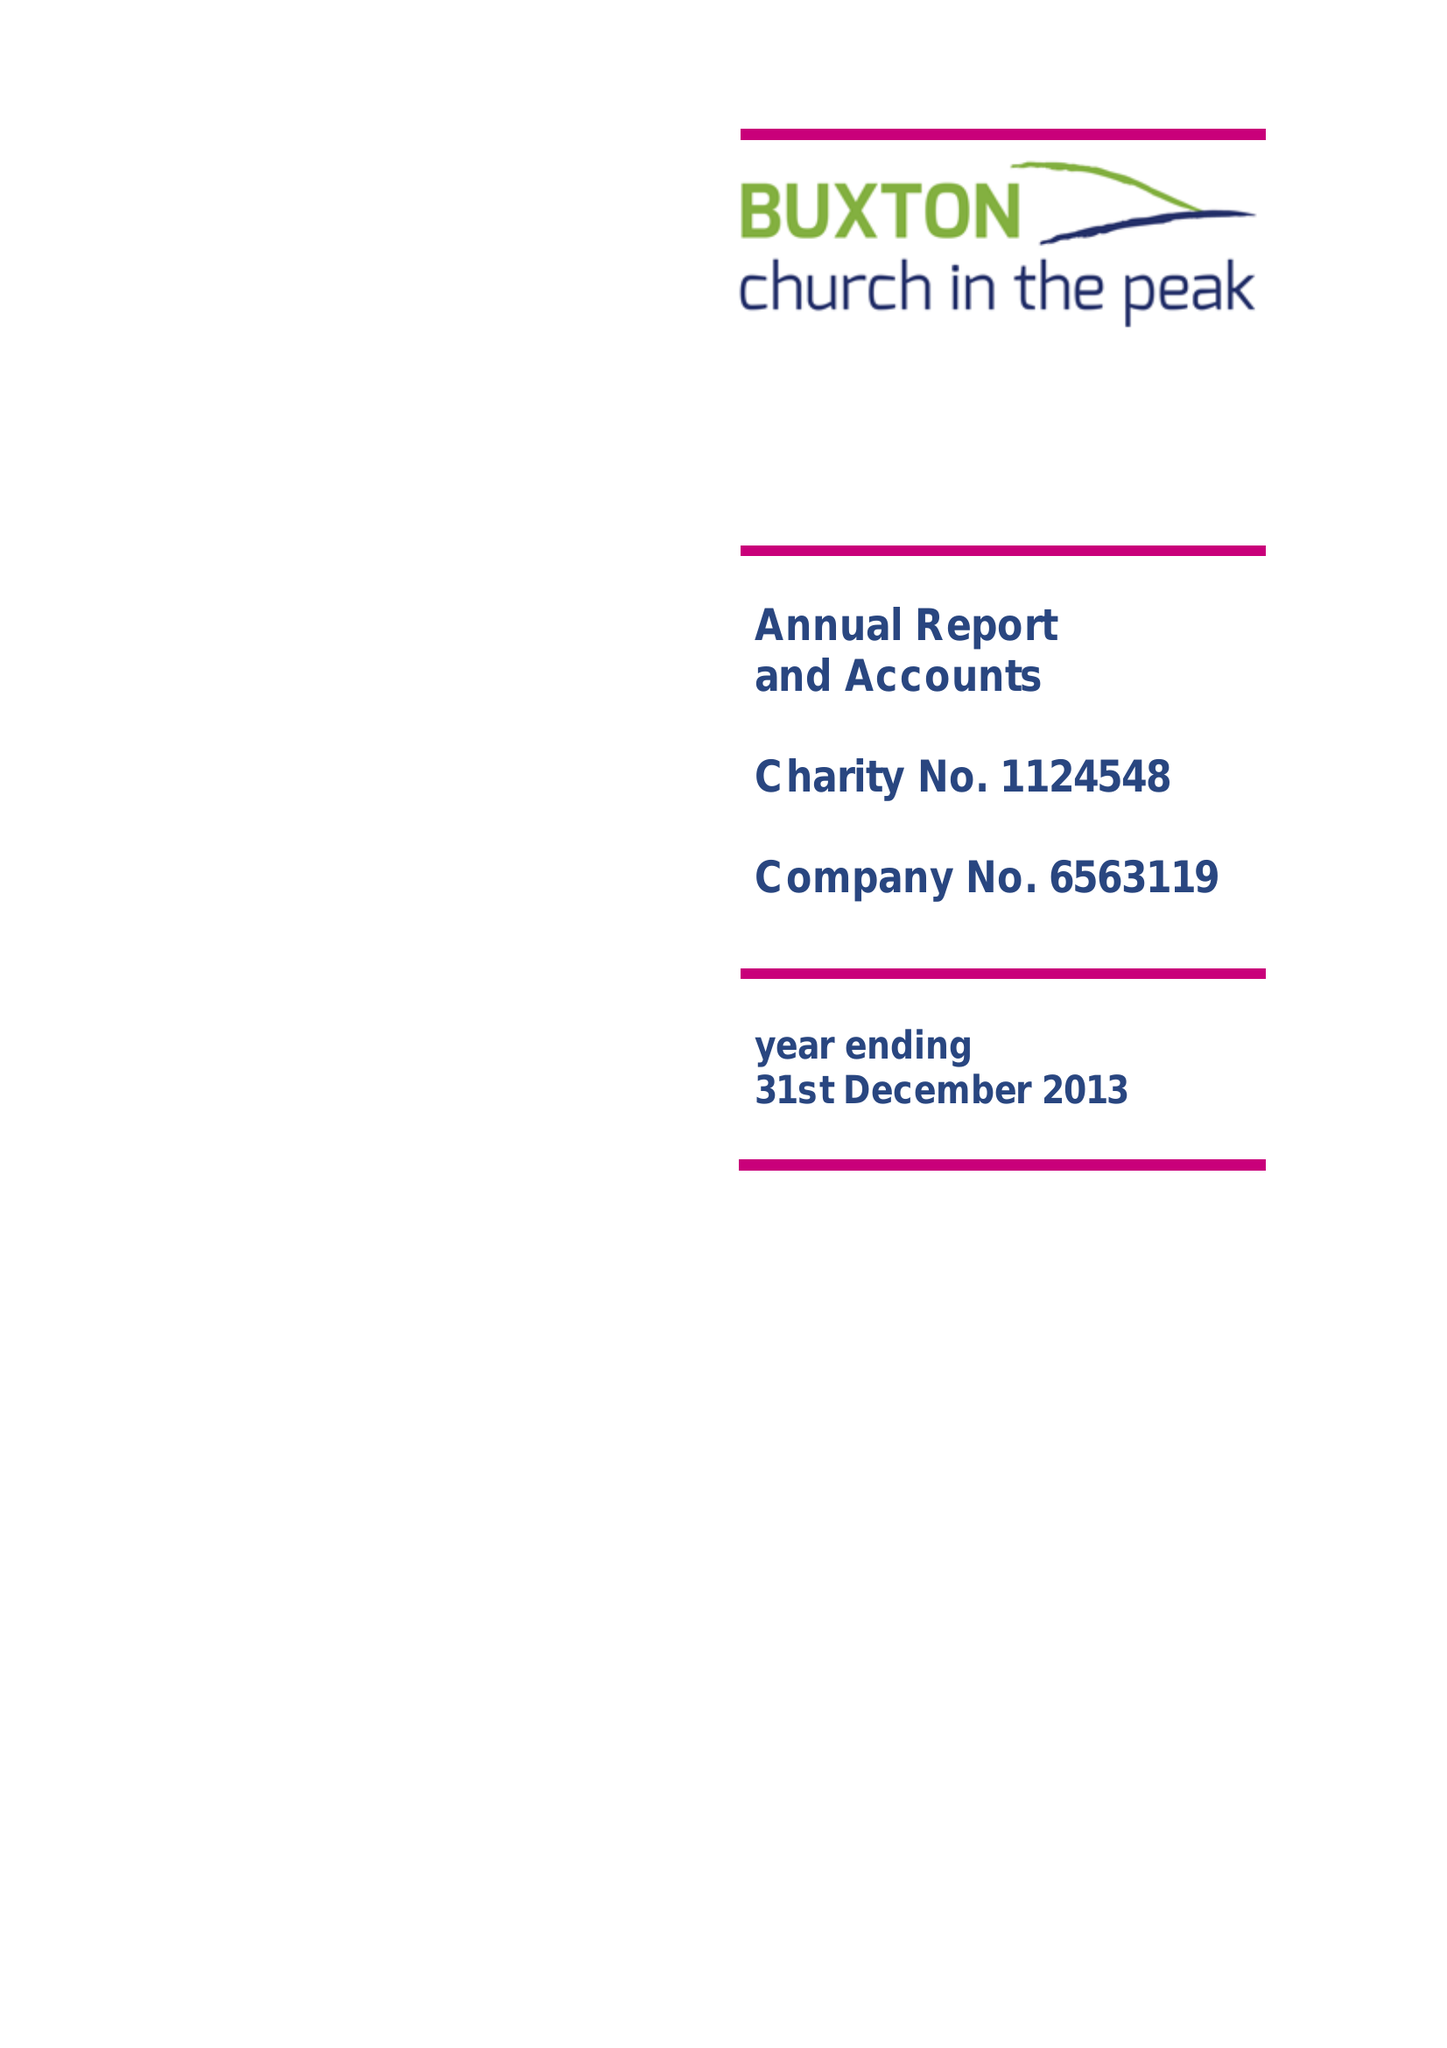What is the value for the charity_name?
Answer the question using a single word or phrase. Buxton Church In The Peak 